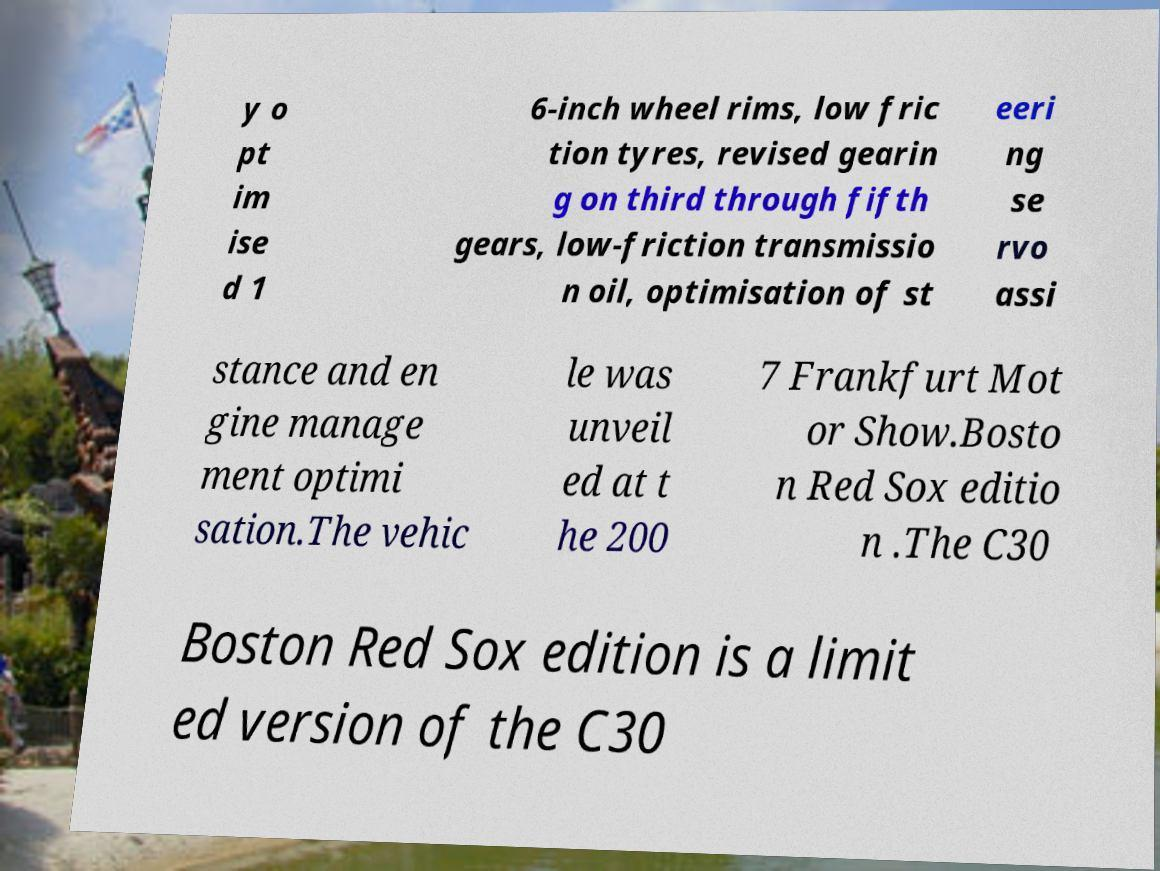Could you assist in decoding the text presented in this image and type it out clearly? y o pt im ise d 1 6-inch wheel rims, low fric tion tyres, revised gearin g on third through fifth gears, low-friction transmissio n oil, optimisation of st eeri ng se rvo assi stance and en gine manage ment optimi sation.The vehic le was unveil ed at t he 200 7 Frankfurt Mot or Show.Bosto n Red Sox editio n .The C30 Boston Red Sox edition is a limit ed version of the C30 